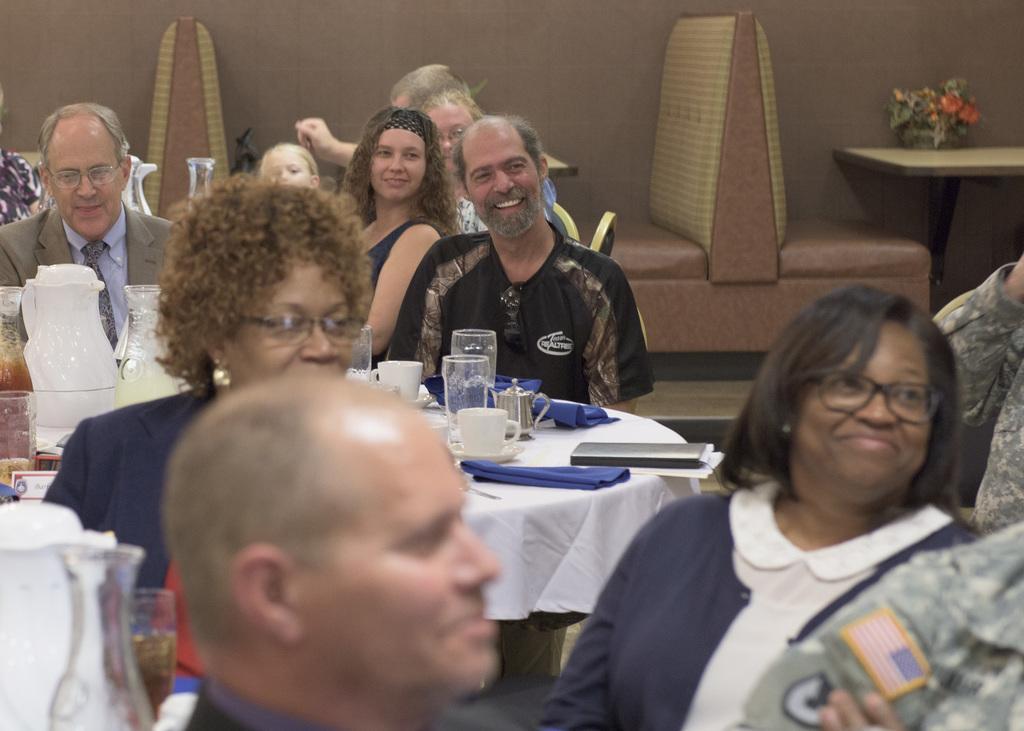How would you summarize this image in a sentence or two? I can see groups of people sitting on the chairs and smiling. This is the table covered with a white cloth. I can see cups and saucers, napkins, glasses, jug and few other things placed on it. These are the couches. I can see another table with a flower bouquet on it. 